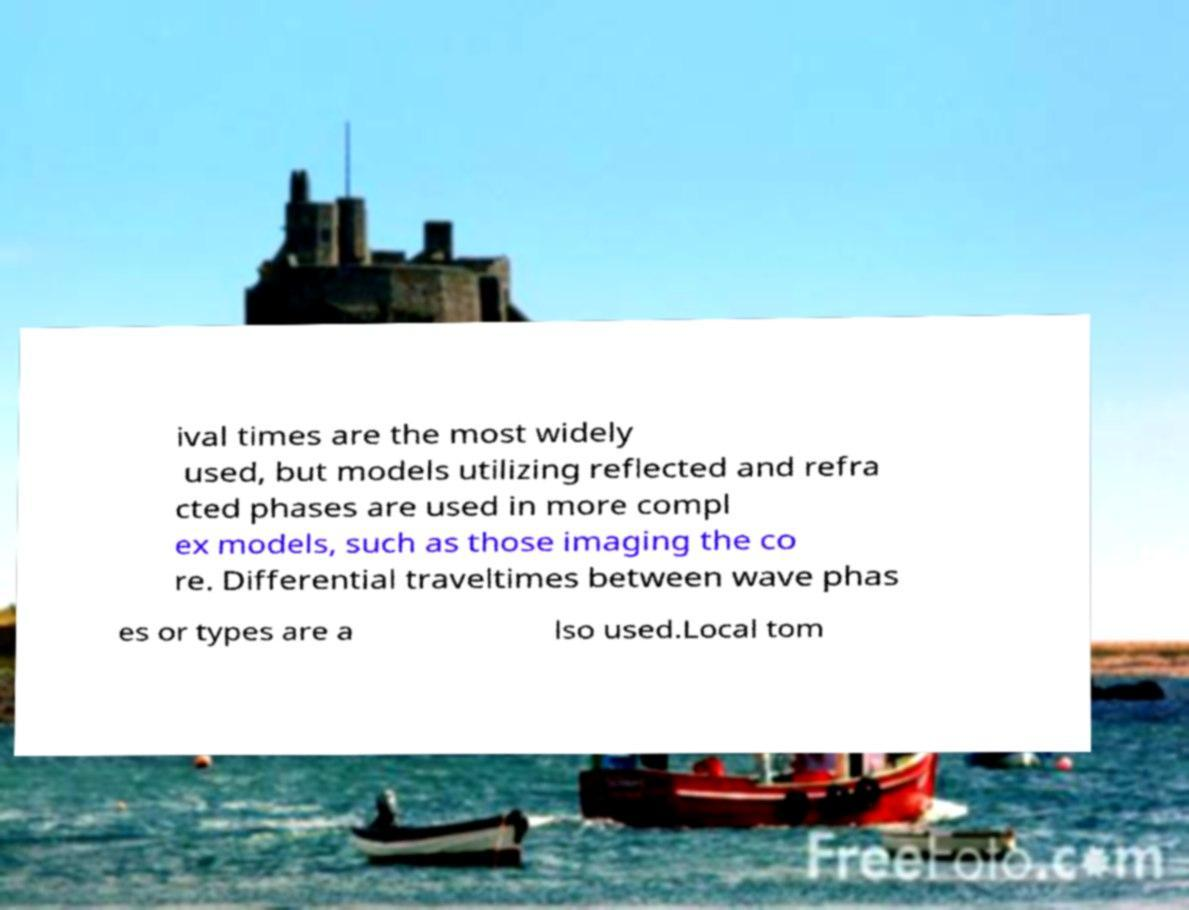Can you read and provide the text displayed in the image?This photo seems to have some interesting text. Can you extract and type it out for me? ival times are the most widely used, but models utilizing reflected and refra cted phases are used in more compl ex models, such as those imaging the co re. Differential traveltimes between wave phas es or types are a lso used.Local tom 